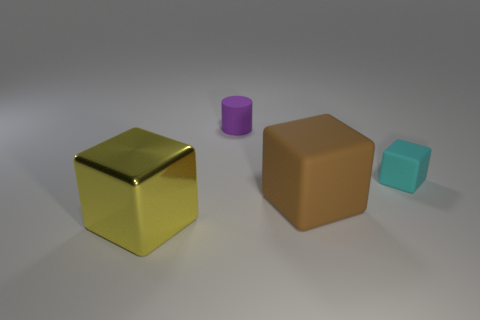Add 1 purple matte objects. How many objects exist? 5 Subtract all blocks. How many objects are left? 1 Subtract 1 brown cubes. How many objects are left? 3 Subtract all tiny blue shiny cubes. Subtract all big yellow metallic blocks. How many objects are left? 3 Add 3 small matte cylinders. How many small matte cylinders are left? 4 Add 4 small purple rubber cylinders. How many small purple rubber cylinders exist? 5 